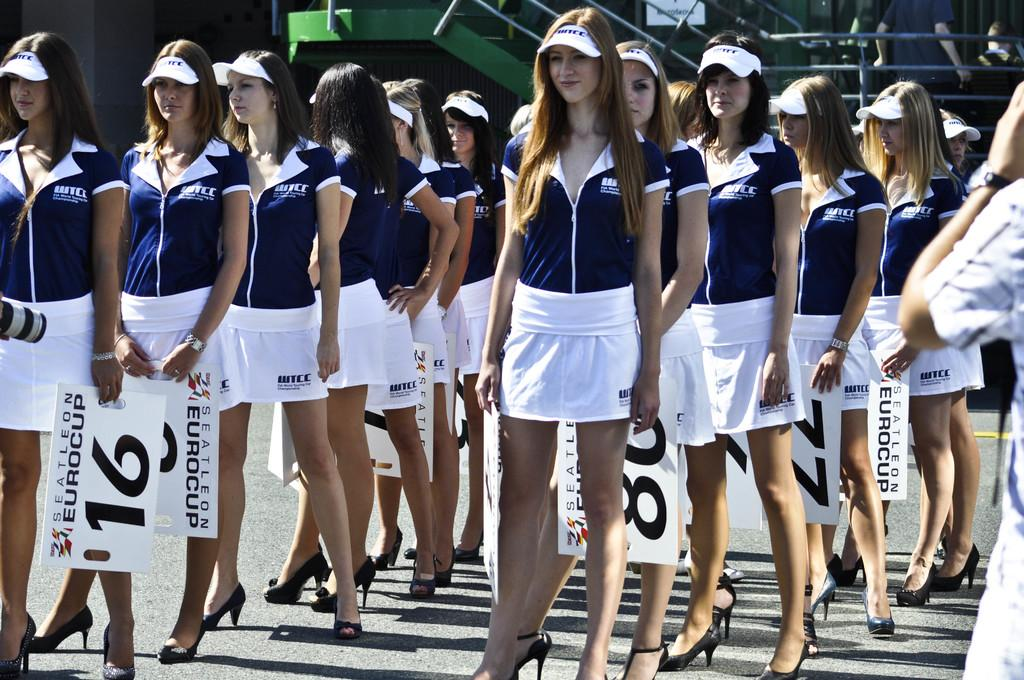<image>
Share a concise interpretation of the image provided. A woman in the front row holds the number 16. 